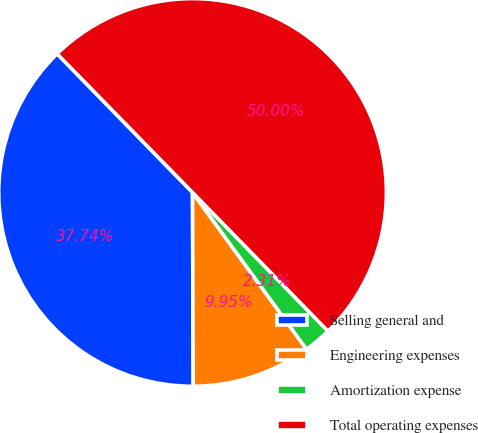Convert chart to OTSL. <chart><loc_0><loc_0><loc_500><loc_500><pie_chart><fcel>Selling general and<fcel>Engineering expenses<fcel>Amortization expense<fcel>Total operating expenses<nl><fcel>37.74%<fcel>9.95%<fcel>2.31%<fcel>50.0%<nl></chart> 